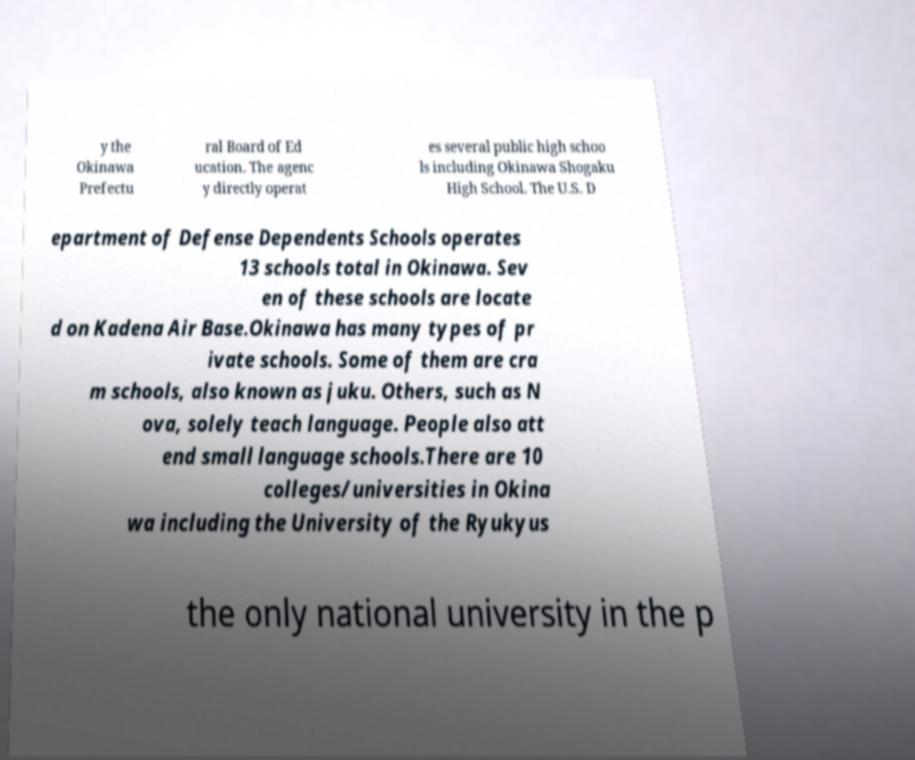There's text embedded in this image that I need extracted. Can you transcribe it verbatim? y the Okinawa Prefectu ral Board of Ed ucation. The agenc y directly operat es several public high schoo ls including Okinawa Shogaku High School. The U.S. D epartment of Defense Dependents Schools operates 13 schools total in Okinawa. Sev en of these schools are locate d on Kadena Air Base.Okinawa has many types of pr ivate schools. Some of them are cra m schools, also known as juku. Others, such as N ova, solely teach language. People also att end small language schools.There are 10 colleges/universities in Okina wa including the University of the Ryukyus the only national university in the p 